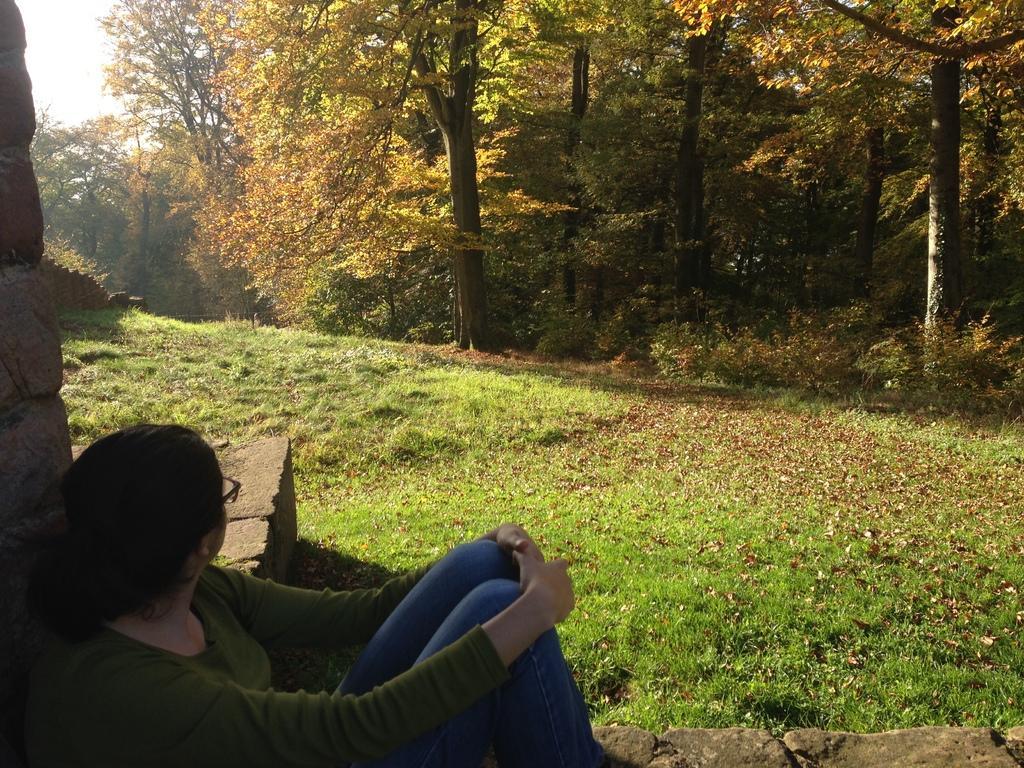Describe this image in one or two sentences. In this image there is a woman who is sitting on the stones at the bottom. In front of her there are so many trees. On the left side there is a stone wall. The woman is lying on the stone wall. 